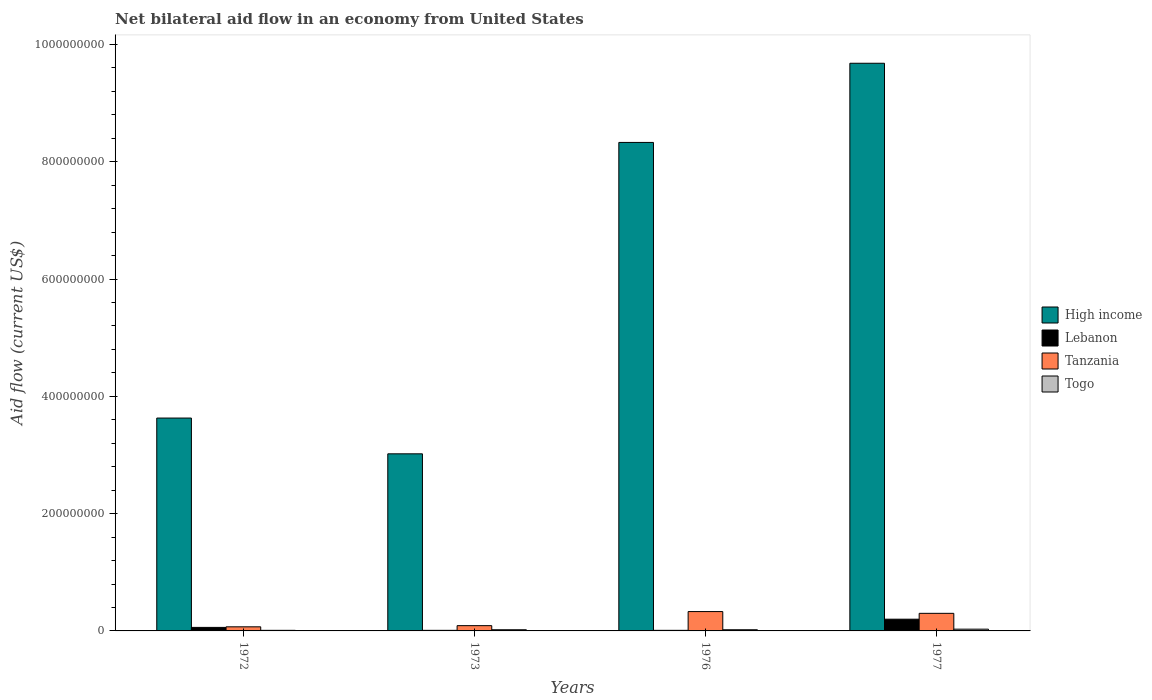How many different coloured bars are there?
Your response must be concise. 4. How many groups of bars are there?
Make the answer very short. 4. Are the number of bars on each tick of the X-axis equal?
Your answer should be compact. Yes. What is the label of the 4th group of bars from the left?
Ensure brevity in your answer.  1977. What is the net bilateral aid flow in High income in 1973?
Keep it short and to the point. 3.02e+08. Across all years, what is the minimum net bilateral aid flow in Tanzania?
Keep it short and to the point. 7.00e+06. In which year was the net bilateral aid flow in Tanzania maximum?
Offer a very short reply. 1976. In which year was the net bilateral aid flow in Tanzania minimum?
Your answer should be compact. 1972. What is the total net bilateral aid flow in High income in the graph?
Make the answer very short. 2.47e+09. What is the difference between the net bilateral aid flow in High income in 1973 and that in 1976?
Provide a succinct answer. -5.31e+08. What is the difference between the net bilateral aid flow in Togo in 1977 and the net bilateral aid flow in High income in 1972?
Offer a terse response. -3.60e+08. What is the average net bilateral aid flow in Lebanon per year?
Provide a succinct answer. 7.00e+06. In the year 1976, what is the difference between the net bilateral aid flow in Lebanon and net bilateral aid flow in High income?
Give a very brief answer. -8.32e+08. What is the ratio of the net bilateral aid flow in High income in 1972 to that in 1976?
Offer a very short reply. 0.44. Is the net bilateral aid flow in High income in 1972 less than that in 1976?
Your answer should be compact. Yes. What is the difference between the highest and the second highest net bilateral aid flow in High income?
Ensure brevity in your answer.  1.35e+08. What is the difference between the highest and the lowest net bilateral aid flow in Lebanon?
Offer a terse response. 1.90e+07. In how many years, is the net bilateral aid flow in Lebanon greater than the average net bilateral aid flow in Lebanon taken over all years?
Give a very brief answer. 1. Is the sum of the net bilateral aid flow in High income in 1976 and 1977 greater than the maximum net bilateral aid flow in Togo across all years?
Your answer should be very brief. Yes. What does the 4th bar from the left in 1973 represents?
Your answer should be compact. Togo. What does the 2nd bar from the right in 1977 represents?
Your answer should be compact. Tanzania. Is it the case that in every year, the sum of the net bilateral aid flow in Tanzania and net bilateral aid flow in Togo is greater than the net bilateral aid flow in Lebanon?
Your answer should be very brief. Yes. What is the difference between two consecutive major ticks on the Y-axis?
Your answer should be very brief. 2.00e+08. Does the graph contain grids?
Ensure brevity in your answer.  No. Where does the legend appear in the graph?
Offer a very short reply. Center right. What is the title of the graph?
Your answer should be very brief. Net bilateral aid flow in an economy from United States. What is the Aid flow (current US$) in High income in 1972?
Offer a very short reply. 3.63e+08. What is the Aid flow (current US$) in Togo in 1972?
Ensure brevity in your answer.  1.00e+06. What is the Aid flow (current US$) of High income in 1973?
Ensure brevity in your answer.  3.02e+08. What is the Aid flow (current US$) of Tanzania in 1973?
Your answer should be very brief. 9.00e+06. What is the Aid flow (current US$) in High income in 1976?
Your answer should be compact. 8.33e+08. What is the Aid flow (current US$) in Lebanon in 1976?
Ensure brevity in your answer.  1.00e+06. What is the Aid flow (current US$) of Tanzania in 1976?
Your answer should be very brief. 3.30e+07. What is the Aid flow (current US$) of Togo in 1976?
Your answer should be compact. 2.00e+06. What is the Aid flow (current US$) in High income in 1977?
Offer a very short reply. 9.68e+08. What is the Aid flow (current US$) in Tanzania in 1977?
Provide a short and direct response. 3.00e+07. Across all years, what is the maximum Aid flow (current US$) of High income?
Give a very brief answer. 9.68e+08. Across all years, what is the maximum Aid flow (current US$) in Tanzania?
Provide a succinct answer. 3.30e+07. Across all years, what is the minimum Aid flow (current US$) of High income?
Offer a terse response. 3.02e+08. Across all years, what is the minimum Aid flow (current US$) of Tanzania?
Ensure brevity in your answer.  7.00e+06. Across all years, what is the minimum Aid flow (current US$) in Togo?
Ensure brevity in your answer.  1.00e+06. What is the total Aid flow (current US$) of High income in the graph?
Offer a terse response. 2.47e+09. What is the total Aid flow (current US$) of Lebanon in the graph?
Offer a very short reply. 2.80e+07. What is the total Aid flow (current US$) in Tanzania in the graph?
Make the answer very short. 7.90e+07. What is the difference between the Aid flow (current US$) of High income in 1972 and that in 1973?
Give a very brief answer. 6.10e+07. What is the difference between the Aid flow (current US$) of Lebanon in 1972 and that in 1973?
Provide a succinct answer. 5.00e+06. What is the difference between the Aid flow (current US$) in Tanzania in 1972 and that in 1973?
Keep it short and to the point. -2.00e+06. What is the difference between the Aid flow (current US$) in Togo in 1972 and that in 1973?
Keep it short and to the point. -1.00e+06. What is the difference between the Aid flow (current US$) of High income in 1972 and that in 1976?
Your answer should be compact. -4.70e+08. What is the difference between the Aid flow (current US$) in Tanzania in 1972 and that in 1976?
Keep it short and to the point. -2.60e+07. What is the difference between the Aid flow (current US$) of High income in 1972 and that in 1977?
Keep it short and to the point. -6.05e+08. What is the difference between the Aid flow (current US$) of Lebanon in 1972 and that in 1977?
Offer a very short reply. -1.40e+07. What is the difference between the Aid flow (current US$) in Tanzania in 1972 and that in 1977?
Give a very brief answer. -2.30e+07. What is the difference between the Aid flow (current US$) of High income in 1973 and that in 1976?
Provide a succinct answer. -5.31e+08. What is the difference between the Aid flow (current US$) of Lebanon in 1973 and that in 1976?
Your response must be concise. 0. What is the difference between the Aid flow (current US$) in Tanzania in 1973 and that in 1976?
Your response must be concise. -2.40e+07. What is the difference between the Aid flow (current US$) of High income in 1973 and that in 1977?
Provide a succinct answer. -6.66e+08. What is the difference between the Aid flow (current US$) in Lebanon in 1973 and that in 1977?
Provide a short and direct response. -1.90e+07. What is the difference between the Aid flow (current US$) in Tanzania in 1973 and that in 1977?
Keep it short and to the point. -2.10e+07. What is the difference between the Aid flow (current US$) in Togo in 1973 and that in 1977?
Make the answer very short. -1.00e+06. What is the difference between the Aid flow (current US$) in High income in 1976 and that in 1977?
Your answer should be compact. -1.35e+08. What is the difference between the Aid flow (current US$) of Lebanon in 1976 and that in 1977?
Offer a terse response. -1.90e+07. What is the difference between the Aid flow (current US$) in Tanzania in 1976 and that in 1977?
Your response must be concise. 3.00e+06. What is the difference between the Aid flow (current US$) of High income in 1972 and the Aid flow (current US$) of Lebanon in 1973?
Provide a succinct answer. 3.62e+08. What is the difference between the Aid flow (current US$) of High income in 1972 and the Aid flow (current US$) of Tanzania in 1973?
Offer a terse response. 3.54e+08. What is the difference between the Aid flow (current US$) in High income in 1972 and the Aid flow (current US$) in Togo in 1973?
Your response must be concise. 3.61e+08. What is the difference between the Aid flow (current US$) in Lebanon in 1972 and the Aid flow (current US$) in Tanzania in 1973?
Offer a terse response. -3.00e+06. What is the difference between the Aid flow (current US$) of High income in 1972 and the Aid flow (current US$) of Lebanon in 1976?
Give a very brief answer. 3.62e+08. What is the difference between the Aid flow (current US$) in High income in 1972 and the Aid flow (current US$) in Tanzania in 1976?
Provide a succinct answer. 3.30e+08. What is the difference between the Aid flow (current US$) in High income in 1972 and the Aid flow (current US$) in Togo in 1976?
Provide a short and direct response. 3.61e+08. What is the difference between the Aid flow (current US$) of Lebanon in 1972 and the Aid flow (current US$) of Tanzania in 1976?
Provide a succinct answer. -2.70e+07. What is the difference between the Aid flow (current US$) in Lebanon in 1972 and the Aid flow (current US$) in Togo in 1976?
Provide a short and direct response. 4.00e+06. What is the difference between the Aid flow (current US$) in High income in 1972 and the Aid flow (current US$) in Lebanon in 1977?
Ensure brevity in your answer.  3.43e+08. What is the difference between the Aid flow (current US$) in High income in 1972 and the Aid flow (current US$) in Tanzania in 1977?
Your answer should be very brief. 3.33e+08. What is the difference between the Aid flow (current US$) in High income in 1972 and the Aid flow (current US$) in Togo in 1977?
Provide a succinct answer. 3.60e+08. What is the difference between the Aid flow (current US$) of Lebanon in 1972 and the Aid flow (current US$) of Tanzania in 1977?
Your answer should be very brief. -2.40e+07. What is the difference between the Aid flow (current US$) in Lebanon in 1972 and the Aid flow (current US$) in Togo in 1977?
Provide a short and direct response. 3.00e+06. What is the difference between the Aid flow (current US$) of Tanzania in 1972 and the Aid flow (current US$) of Togo in 1977?
Give a very brief answer. 4.00e+06. What is the difference between the Aid flow (current US$) of High income in 1973 and the Aid flow (current US$) of Lebanon in 1976?
Provide a short and direct response. 3.01e+08. What is the difference between the Aid flow (current US$) of High income in 1973 and the Aid flow (current US$) of Tanzania in 1976?
Provide a succinct answer. 2.69e+08. What is the difference between the Aid flow (current US$) in High income in 1973 and the Aid flow (current US$) in Togo in 1976?
Offer a terse response. 3.00e+08. What is the difference between the Aid flow (current US$) in Lebanon in 1973 and the Aid flow (current US$) in Tanzania in 1976?
Make the answer very short. -3.20e+07. What is the difference between the Aid flow (current US$) of Lebanon in 1973 and the Aid flow (current US$) of Togo in 1976?
Give a very brief answer. -1.00e+06. What is the difference between the Aid flow (current US$) in High income in 1973 and the Aid flow (current US$) in Lebanon in 1977?
Make the answer very short. 2.82e+08. What is the difference between the Aid flow (current US$) of High income in 1973 and the Aid flow (current US$) of Tanzania in 1977?
Ensure brevity in your answer.  2.72e+08. What is the difference between the Aid flow (current US$) in High income in 1973 and the Aid flow (current US$) in Togo in 1977?
Offer a terse response. 2.99e+08. What is the difference between the Aid flow (current US$) in Lebanon in 1973 and the Aid flow (current US$) in Tanzania in 1977?
Offer a very short reply. -2.90e+07. What is the difference between the Aid flow (current US$) of Tanzania in 1973 and the Aid flow (current US$) of Togo in 1977?
Your response must be concise. 6.00e+06. What is the difference between the Aid flow (current US$) in High income in 1976 and the Aid flow (current US$) in Lebanon in 1977?
Ensure brevity in your answer.  8.13e+08. What is the difference between the Aid flow (current US$) of High income in 1976 and the Aid flow (current US$) of Tanzania in 1977?
Give a very brief answer. 8.03e+08. What is the difference between the Aid flow (current US$) of High income in 1976 and the Aid flow (current US$) of Togo in 1977?
Ensure brevity in your answer.  8.30e+08. What is the difference between the Aid flow (current US$) in Lebanon in 1976 and the Aid flow (current US$) in Tanzania in 1977?
Offer a very short reply. -2.90e+07. What is the difference between the Aid flow (current US$) in Tanzania in 1976 and the Aid flow (current US$) in Togo in 1977?
Ensure brevity in your answer.  3.00e+07. What is the average Aid flow (current US$) in High income per year?
Offer a very short reply. 6.16e+08. What is the average Aid flow (current US$) of Lebanon per year?
Your response must be concise. 7.00e+06. What is the average Aid flow (current US$) of Tanzania per year?
Offer a very short reply. 1.98e+07. What is the average Aid flow (current US$) in Togo per year?
Offer a very short reply. 2.00e+06. In the year 1972, what is the difference between the Aid flow (current US$) in High income and Aid flow (current US$) in Lebanon?
Offer a terse response. 3.57e+08. In the year 1972, what is the difference between the Aid flow (current US$) in High income and Aid flow (current US$) in Tanzania?
Provide a short and direct response. 3.56e+08. In the year 1972, what is the difference between the Aid flow (current US$) in High income and Aid flow (current US$) in Togo?
Give a very brief answer. 3.62e+08. In the year 1972, what is the difference between the Aid flow (current US$) in Tanzania and Aid flow (current US$) in Togo?
Make the answer very short. 6.00e+06. In the year 1973, what is the difference between the Aid flow (current US$) of High income and Aid flow (current US$) of Lebanon?
Offer a terse response. 3.01e+08. In the year 1973, what is the difference between the Aid flow (current US$) in High income and Aid flow (current US$) in Tanzania?
Ensure brevity in your answer.  2.93e+08. In the year 1973, what is the difference between the Aid flow (current US$) in High income and Aid flow (current US$) in Togo?
Provide a short and direct response. 3.00e+08. In the year 1973, what is the difference between the Aid flow (current US$) of Lebanon and Aid flow (current US$) of Tanzania?
Your response must be concise. -8.00e+06. In the year 1973, what is the difference between the Aid flow (current US$) of Lebanon and Aid flow (current US$) of Togo?
Your answer should be compact. -1.00e+06. In the year 1976, what is the difference between the Aid flow (current US$) in High income and Aid flow (current US$) in Lebanon?
Ensure brevity in your answer.  8.32e+08. In the year 1976, what is the difference between the Aid flow (current US$) in High income and Aid flow (current US$) in Tanzania?
Your answer should be very brief. 8.00e+08. In the year 1976, what is the difference between the Aid flow (current US$) in High income and Aid flow (current US$) in Togo?
Your answer should be very brief. 8.31e+08. In the year 1976, what is the difference between the Aid flow (current US$) of Lebanon and Aid flow (current US$) of Tanzania?
Make the answer very short. -3.20e+07. In the year 1976, what is the difference between the Aid flow (current US$) of Lebanon and Aid flow (current US$) of Togo?
Your response must be concise. -1.00e+06. In the year 1976, what is the difference between the Aid flow (current US$) of Tanzania and Aid flow (current US$) of Togo?
Your response must be concise. 3.10e+07. In the year 1977, what is the difference between the Aid flow (current US$) in High income and Aid flow (current US$) in Lebanon?
Ensure brevity in your answer.  9.48e+08. In the year 1977, what is the difference between the Aid flow (current US$) of High income and Aid flow (current US$) of Tanzania?
Make the answer very short. 9.38e+08. In the year 1977, what is the difference between the Aid flow (current US$) of High income and Aid flow (current US$) of Togo?
Make the answer very short. 9.65e+08. In the year 1977, what is the difference between the Aid flow (current US$) in Lebanon and Aid flow (current US$) in Tanzania?
Make the answer very short. -1.00e+07. In the year 1977, what is the difference between the Aid flow (current US$) of Lebanon and Aid flow (current US$) of Togo?
Offer a very short reply. 1.70e+07. In the year 1977, what is the difference between the Aid flow (current US$) of Tanzania and Aid flow (current US$) of Togo?
Your answer should be very brief. 2.70e+07. What is the ratio of the Aid flow (current US$) in High income in 1972 to that in 1973?
Give a very brief answer. 1.2. What is the ratio of the Aid flow (current US$) of Lebanon in 1972 to that in 1973?
Offer a terse response. 6. What is the ratio of the Aid flow (current US$) of High income in 1972 to that in 1976?
Give a very brief answer. 0.44. What is the ratio of the Aid flow (current US$) in Tanzania in 1972 to that in 1976?
Provide a short and direct response. 0.21. What is the ratio of the Aid flow (current US$) of Togo in 1972 to that in 1976?
Offer a very short reply. 0.5. What is the ratio of the Aid flow (current US$) of High income in 1972 to that in 1977?
Make the answer very short. 0.38. What is the ratio of the Aid flow (current US$) of Lebanon in 1972 to that in 1977?
Provide a succinct answer. 0.3. What is the ratio of the Aid flow (current US$) in Tanzania in 1972 to that in 1977?
Give a very brief answer. 0.23. What is the ratio of the Aid flow (current US$) of High income in 1973 to that in 1976?
Offer a terse response. 0.36. What is the ratio of the Aid flow (current US$) in Tanzania in 1973 to that in 1976?
Your answer should be very brief. 0.27. What is the ratio of the Aid flow (current US$) in Togo in 1973 to that in 1976?
Offer a very short reply. 1. What is the ratio of the Aid flow (current US$) of High income in 1973 to that in 1977?
Offer a very short reply. 0.31. What is the ratio of the Aid flow (current US$) in Tanzania in 1973 to that in 1977?
Your answer should be very brief. 0.3. What is the ratio of the Aid flow (current US$) in High income in 1976 to that in 1977?
Your answer should be very brief. 0.86. What is the ratio of the Aid flow (current US$) of Lebanon in 1976 to that in 1977?
Keep it short and to the point. 0.05. What is the ratio of the Aid flow (current US$) in Tanzania in 1976 to that in 1977?
Your response must be concise. 1.1. What is the difference between the highest and the second highest Aid flow (current US$) in High income?
Provide a short and direct response. 1.35e+08. What is the difference between the highest and the second highest Aid flow (current US$) of Lebanon?
Make the answer very short. 1.40e+07. What is the difference between the highest and the second highest Aid flow (current US$) in Tanzania?
Provide a short and direct response. 3.00e+06. What is the difference between the highest and the second highest Aid flow (current US$) of Togo?
Give a very brief answer. 1.00e+06. What is the difference between the highest and the lowest Aid flow (current US$) of High income?
Make the answer very short. 6.66e+08. What is the difference between the highest and the lowest Aid flow (current US$) of Lebanon?
Give a very brief answer. 1.90e+07. What is the difference between the highest and the lowest Aid flow (current US$) in Tanzania?
Make the answer very short. 2.60e+07. 